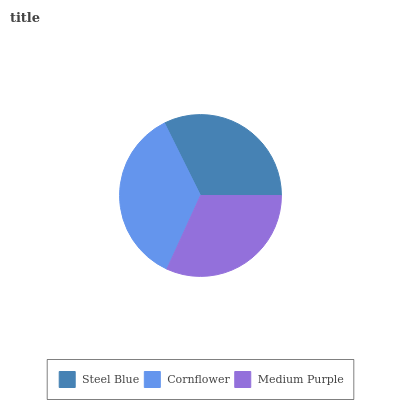Is Medium Purple the minimum?
Answer yes or no. Yes. Is Cornflower the maximum?
Answer yes or no. Yes. Is Cornflower the minimum?
Answer yes or no. No. Is Medium Purple the maximum?
Answer yes or no. No. Is Cornflower greater than Medium Purple?
Answer yes or no. Yes. Is Medium Purple less than Cornflower?
Answer yes or no. Yes. Is Medium Purple greater than Cornflower?
Answer yes or no. No. Is Cornflower less than Medium Purple?
Answer yes or no. No. Is Steel Blue the high median?
Answer yes or no. Yes. Is Steel Blue the low median?
Answer yes or no. Yes. Is Medium Purple the high median?
Answer yes or no. No. Is Cornflower the low median?
Answer yes or no. No. 